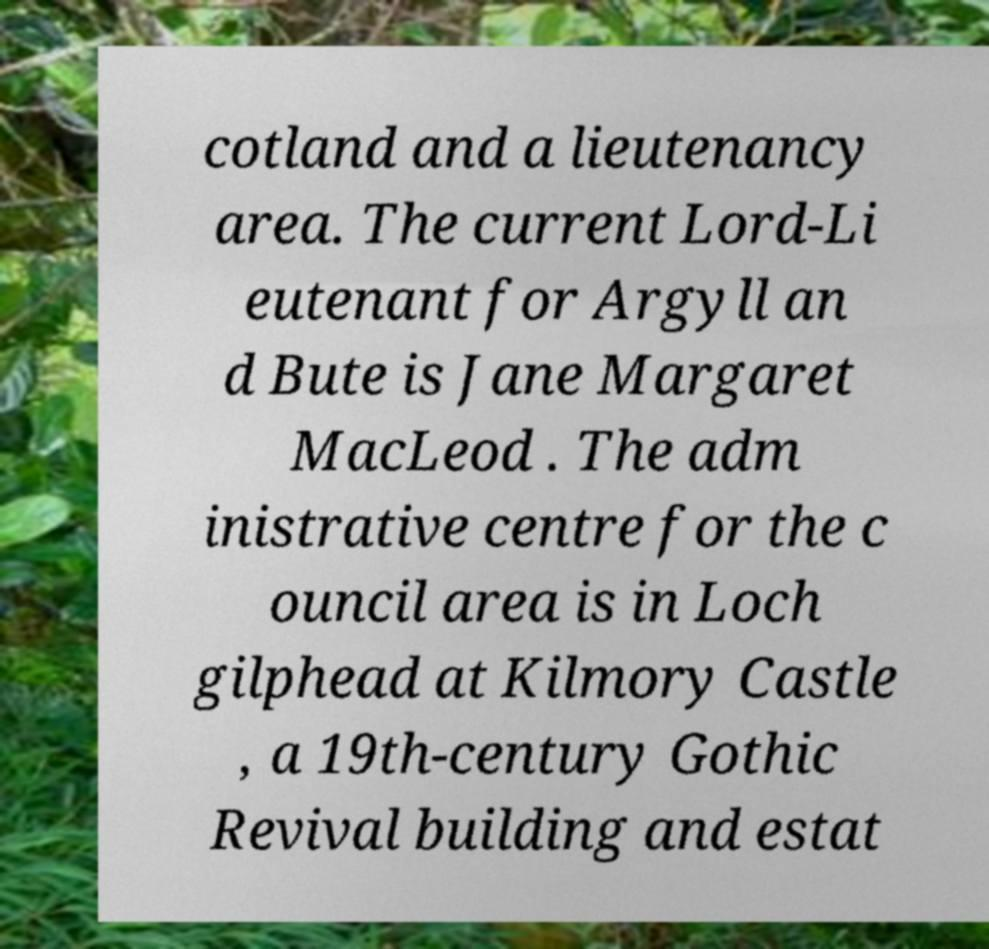What messages or text are displayed in this image? I need them in a readable, typed format. cotland and a lieutenancy area. The current Lord-Li eutenant for Argyll an d Bute is Jane Margaret MacLeod . The adm inistrative centre for the c ouncil area is in Loch gilphead at Kilmory Castle , a 19th-century Gothic Revival building and estat 